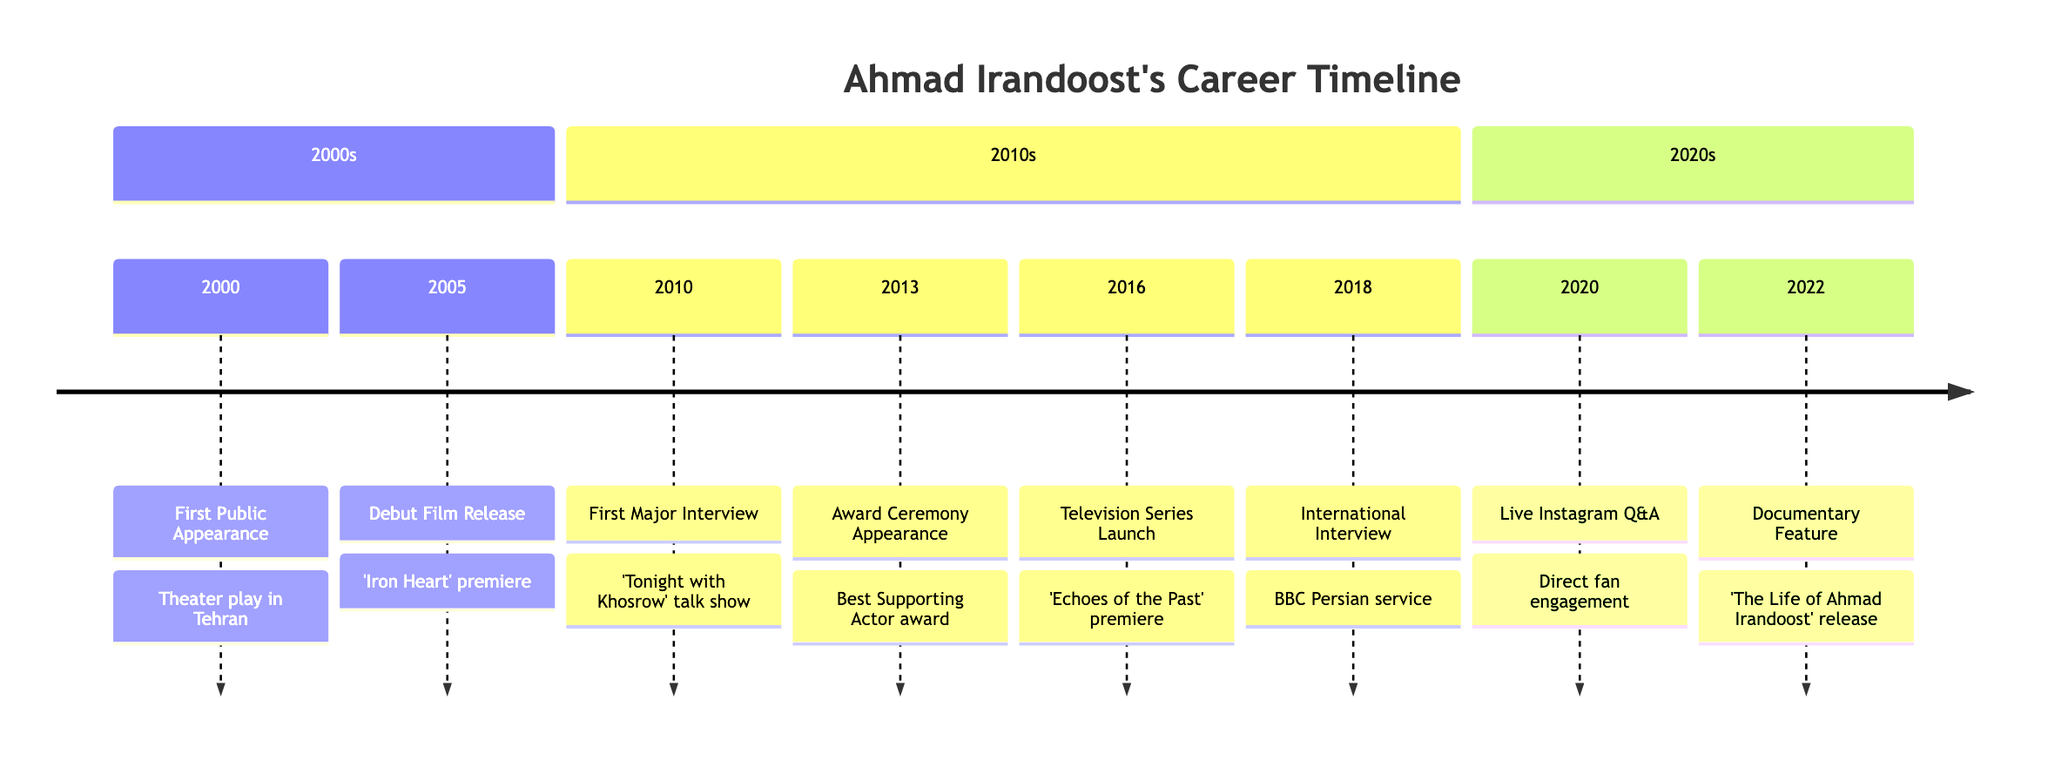What is the date of Ahmad Irandoost's first public appearance? The timeline indicates that Ahmad Irandoost's first public appearance was on March 15, 2000. This is the earliest event listed in the timeline.
Answer: March 15, 2000 What event occurred immediately after the debut film release? The event that follows the debut film release (which occurred on September 22, 2005) is Ahmad Irandoost's first major interview on July 8, 2010. By checking the sequence of events, we establish the order.
Answer: First Major Interview How many years passed between Ahmad Irandoost's first public appearance and his first major interview? Ahmad Irandoost's first public appearance was in 2000 and his first major interview was in 2010, which is a total of 10 years. This is calculated by subtracting the years (2010 - 2000).
Answer: 10 years What was the title of the documentary released about Ahmad Irandoost in 2022? The timeline specifically states that the documentary titled "The Life of Ahmad Irandoost" was released on June 30, 2022. This is stated under the last event of 2022 in the timeline.
Answer: The Life of Ahmad Irandoost What significant international media appearance did Ahmad Irandoost make in 2018? In 2018, Ahmad Irandoost was interviewed by the BBC Persian service, which is his first significant international media appearance. This is clearly stated as an event in the timeline.
Answer: BBC Persian service How many total public appearances and interviews are documented in the timeline? By counting the unique events, there are 8 documented appearances and interviews related to Ahmad Irandoost. Each event in the timeline represents a separate occurrence.
Answer: 8 Which award did Ahmad Irandoost receive in 2013? The timeline notes that Ahmad Irandoost received the Best Supporting Actor award at the Iranian Film Awards on November 5, 2013. This information is directly given in the timeline.
Answer: Best Supporting Actor Which year did Ahmad Irandoost host a live Q&A on Instagram? According to the timeline, Ahmad Irandoost hosted a live Q&A session on Instagram on November 11, 2020. This date is explicitly stated in the corresponding event.
Answer: 2020 